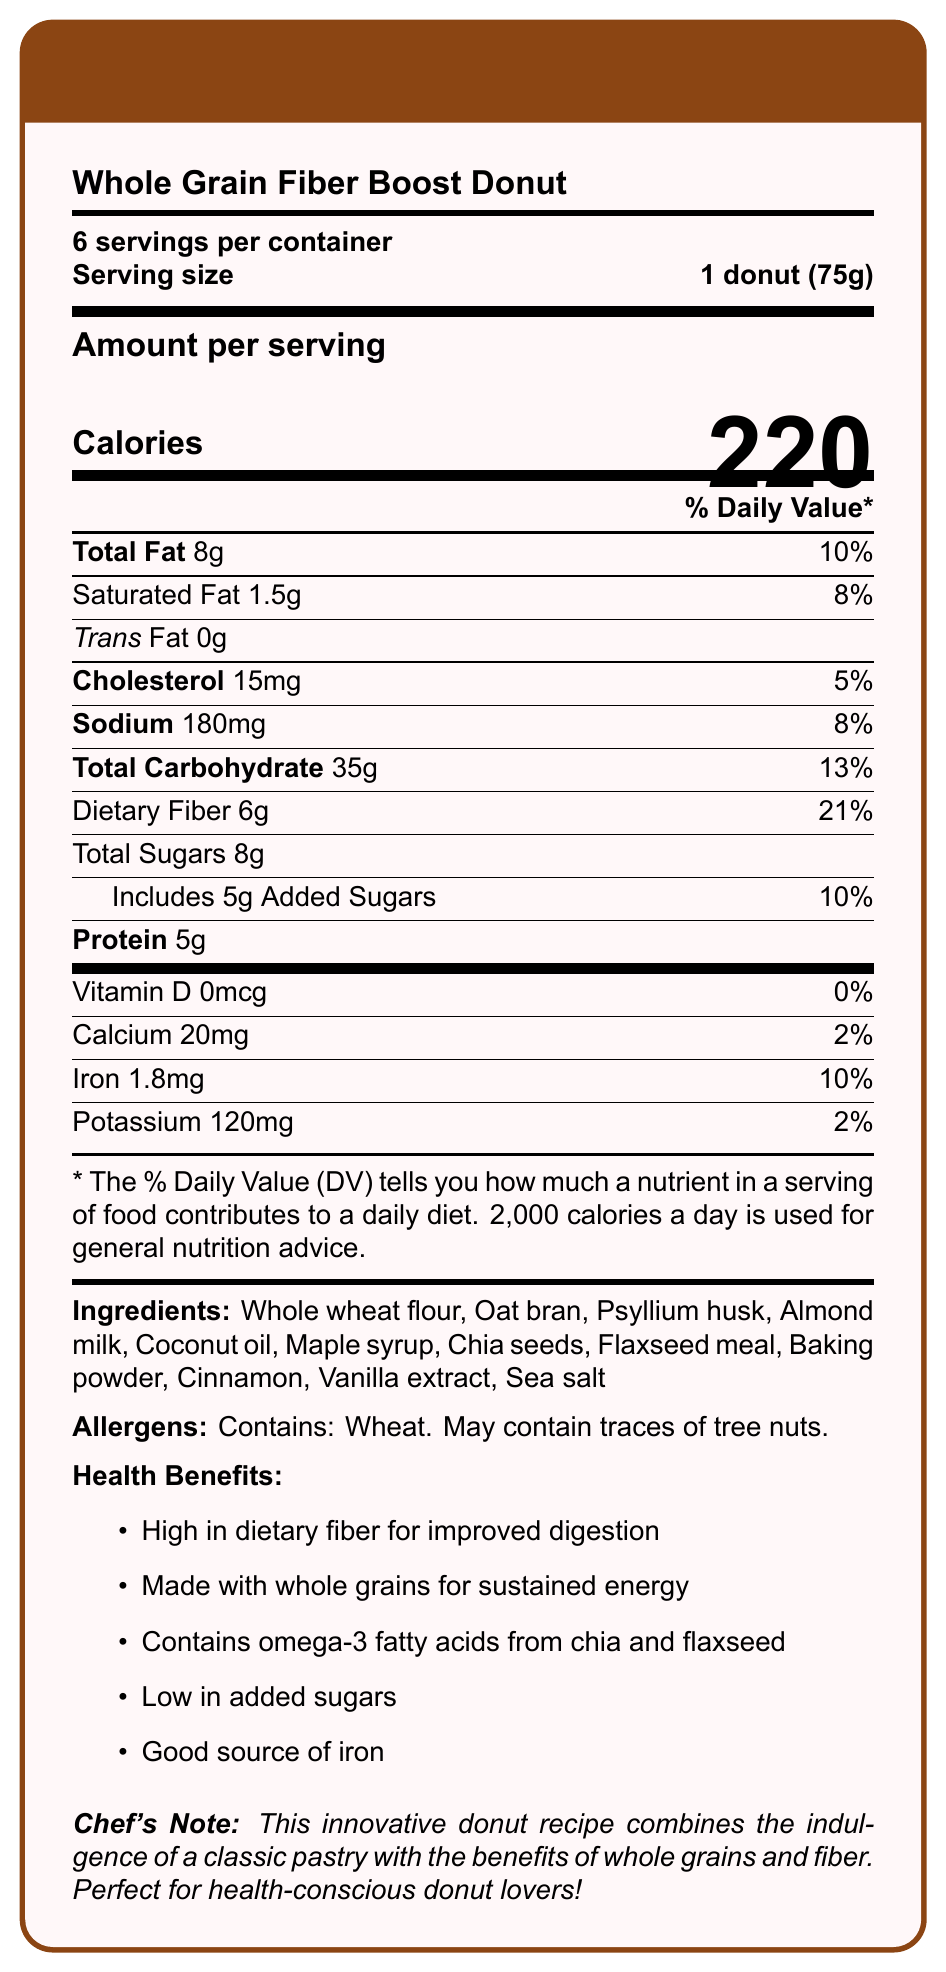what is the serving size? The serving size is specified as "1 donut (75g)" under the "Serving size" section of the document.
Answer: 1 donut (75g) how many calories are in one serving of the donut? The number of calories per serving is shown prominently as "220" under the "Amount per serving" section.
Answer: 220 what is the percentage of the daily value of dietary fiber in one serving? The percentage of the daily value for dietary fiber is listed as 21% under the "Dietary Fiber" section.
Answer: 21% how many grams of total fat are in one donut? The total fat content per serving is listed as 8g in the "Total Fat" section.
Answer: 8g what is the main ingredient in the Whole Grain Fiber Boost Donut? The first ingredient listed in the "Ingredients" section is "Whole wheat flour".
Answer: Whole wheat flour does the Whole Grain Fiber Boost Donut contain trans fat? The "Trans Fat" section indicates "0g", meaning there is no trans fat in the donut.
Answer: No how much protein does one serving of the donut contain? The "Protein" section lists the protein content as 5g per serving.
Answer: 5g which of the following health benefits is NOT listed for the Whole Grain Fiber Boost Donut? A. High in dietary fiber B. Contains omega-3 fatty acids C. Rich in vitamin D D. Low in added sugars The "Health Benefits" section lists all other options except for "Rich in vitamin D".
Answer: C which of the following allergens is mentioned in the document? A. Dairy B. Wheat C. Soy D. Peanuts The "Allergens" section mentions "Contains: Wheat".
Answer: B what is the daily value percentage of iron in one serving? The daily value percentage for iron is listed as 10% under the "Iron" section.
Answer: 10% describe the main idea of the document The document details the nutritional content of the Whole Grain Fiber Boost Donut, including calories, fats, cholesterol, sodium, carbohydrates, protein, vitamins, and minerals. It also lists the ingredients, allergen information, and various health benefits. A note from the chef is included, highlighting the combination of indulgence and health benefits.
Answer: The document is a Nutrition Facts Label for a Whole Grain Fiber Boost Donut. It provides detailed nutritional information, ingredients, health benefits, and allergen warnings to help consumers make informed choices. is there any vitamin D in this donut? The "Vitamin D" section indicates "0mcg", meaning there is no vitamin D in the donut.
Answer: No how many servings are there per container? The document specifies "6 servings per container" under the servings section.
Answer: 6 what are the primary benefits of consuming this donut? The "Health Benefits" section lists primary benefits such as high dietary fiber for improved digestion, whole grains for sustained energy, omega-3 fatty acids, low added sugars, and being a good source of iron.
Answer: Improved digestion, sustained energy, omega-3 fatty acids, low added sugars, good source of iron what is the sodium content in one serving? The "Sodium" section lists the sodium content as 180mg per serving.
Answer: 180mg does this donut contain any dairy products? The ingredients list includes "Almond milk," which is not a dairy product, but doesn't confirm the absence of dairy. The allergen information doesn't specify dairy either.
Answer: Cannot be determined what kind of oil is used in the Whole Grain Fiber Boost Donut? The ingredients list includes "Coconut oil" as one of the components.
Answer: Coconut oil how much added sugars are in one serving? The "Includes 5g Added Sugars" section states that there are 5g of added sugars per serving.
Answer: 5g does the document mention any specific note from the chef? The document includes a "Chef's Note" which mentions that the donut combines indulgence with health benefits, making it perfect for health-conscious donut lovers.
Answer: Yes 